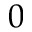<formula> <loc_0><loc_0><loc_500><loc_500>0</formula> 